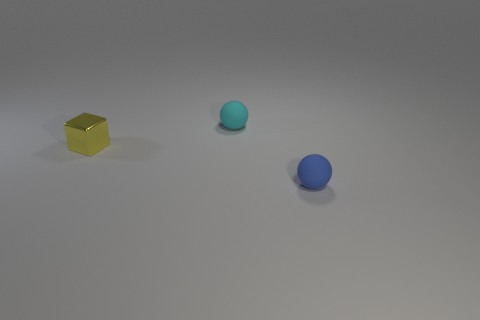Does the sphere that is on the right side of the cyan object have the same material as the yellow object?
Your answer should be compact. No. How many tiny matte things are there?
Make the answer very short. 2. What number of objects are either cyan metallic balls or cyan matte objects?
Offer a very short reply. 1. There is a rubber ball that is in front of the rubber sphere that is behind the small blue object; how many rubber balls are to the left of it?
Your answer should be compact. 1. Is there anything else that has the same color as the block?
Your answer should be compact. No. Does the sphere behind the small yellow block have the same color as the small rubber sphere in front of the small cube?
Your response must be concise. No. Is the number of things to the right of the small blue rubber ball greater than the number of blue rubber spheres that are behind the cyan sphere?
Your answer should be compact. No. What is the material of the tiny cyan object?
Give a very brief answer. Rubber. There is a matte object behind the ball that is in front of the tiny rubber object that is behind the blue rubber thing; what is its shape?
Offer a very short reply. Sphere. How many other objects are there of the same material as the small blue sphere?
Provide a short and direct response. 1. 